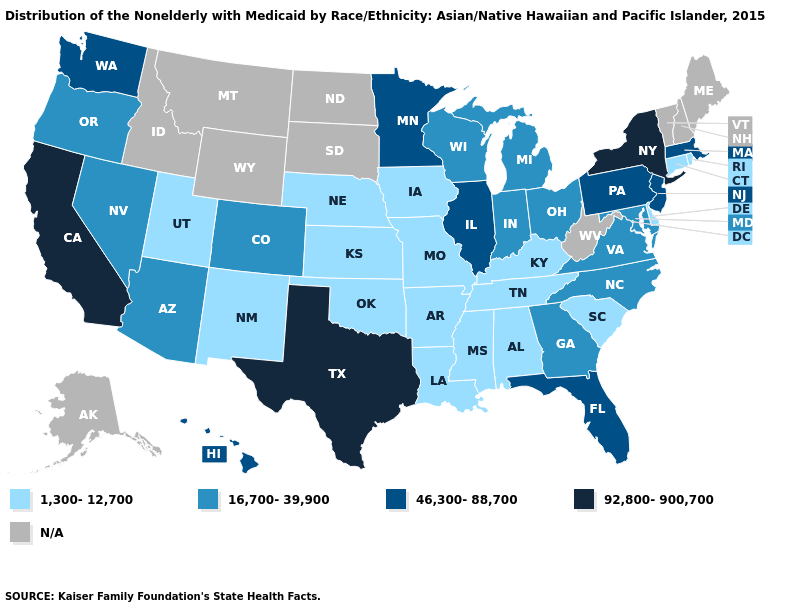Name the states that have a value in the range N/A?
Quick response, please. Alaska, Idaho, Maine, Montana, New Hampshire, North Dakota, South Dakota, Vermont, West Virginia, Wyoming. What is the highest value in the Northeast ?
Quick response, please. 92,800-900,700. Name the states that have a value in the range 92,800-900,700?
Write a very short answer. California, New York, Texas. Which states have the lowest value in the West?
Be succinct. New Mexico, Utah. What is the value of Mississippi?
Answer briefly. 1,300-12,700. Among the states that border Ohio , which have the lowest value?
Write a very short answer. Kentucky. Does South Carolina have the lowest value in the South?
Be succinct. Yes. Which states have the highest value in the USA?
Answer briefly. California, New York, Texas. What is the value of Washington?
Write a very short answer. 46,300-88,700. Does Minnesota have the highest value in the MidWest?
Quick response, please. Yes. How many symbols are there in the legend?
Give a very brief answer. 5. What is the highest value in the USA?
Answer briefly. 92,800-900,700. Does Wisconsin have the lowest value in the USA?
Answer briefly. No. What is the lowest value in the MidWest?
Quick response, please. 1,300-12,700. Name the states that have a value in the range 1,300-12,700?
Give a very brief answer. Alabama, Arkansas, Connecticut, Delaware, Iowa, Kansas, Kentucky, Louisiana, Mississippi, Missouri, Nebraska, New Mexico, Oklahoma, Rhode Island, South Carolina, Tennessee, Utah. 